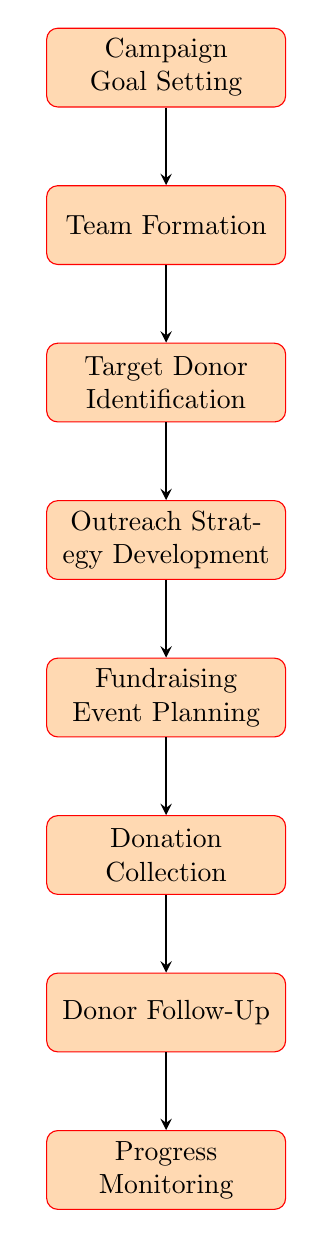What is the first step in the fundraising workflow? The diagram identifies "Campaign Goal Setting" as the first node in the workflow, indicating it is the initial step that sets the foundation for the entire fundraising process.
Answer: Campaign Goal Setting How many nodes are present in the diagram? The diagram shows a total of 8 nodes, each representing a step in the fundraising workflow.
Answer: 8 What comes after "Donation Collection"? The flow indicates that "Donor Follow-Up" is the next step that follows "Donation Collection", suggesting a process of engaging with donors after their contributions.
Answer: Donor Follow-Up Which node is directly connected to "Target Donor Identification"? "Outreach Strategy Development" is the node that directly follows "Target Donor Identification", indicating that strategies for outreach are developed after identifying target donors.
Answer: Outreach Strategy Development What is the last step in this fundraising workflow? The diagram concludes with "Progress Monitoring" as the final node, indicating this is the last action taken to assess the overall effectiveness of the fundraising efforts.
Answer: Progress Monitoring How does a team begin their fundraising activities? The workflow indicates that after "Campaign Goal Setting", the team formation occurs, suggesting that a structured team is essential right after the goals are established.
Answer: Team Formation What type of events are planned in the fundraising workflow? The diagram specifies "Fundraising Event Planning", indicating that various events like town halls and meet-and-greets are organized as part of the fundraising strategy.
Answer: Fundraising Event Planning What process is indicated after "Donor Follow-Up"? "Progress Monitoring" follows "Donor Follow-Up", indicating a continuous improvement stage in the fundraising workflow that assesses past donor engagement.
Answer: Progress Monitoring Which process identifies key donor segments? "Target Donor Identification" is the specified process that is responsible for identifying key donor segments, suggesting the initial targeting phase of the fundraising strategy.
Answer: Target Donor Identification 